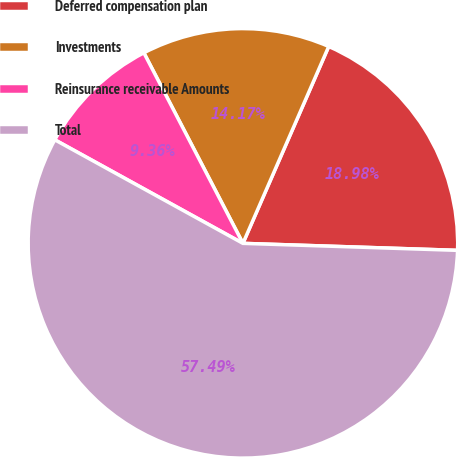Convert chart to OTSL. <chart><loc_0><loc_0><loc_500><loc_500><pie_chart><fcel>Deferred compensation plan<fcel>Investments<fcel>Reinsurance receivable Amounts<fcel>Total<nl><fcel>18.98%<fcel>14.17%<fcel>9.36%<fcel>57.49%<nl></chart> 